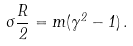<formula> <loc_0><loc_0><loc_500><loc_500>\sigma \frac { R } { 2 } = m ( \gamma ^ { 2 } - 1 ) \, .</formula> 